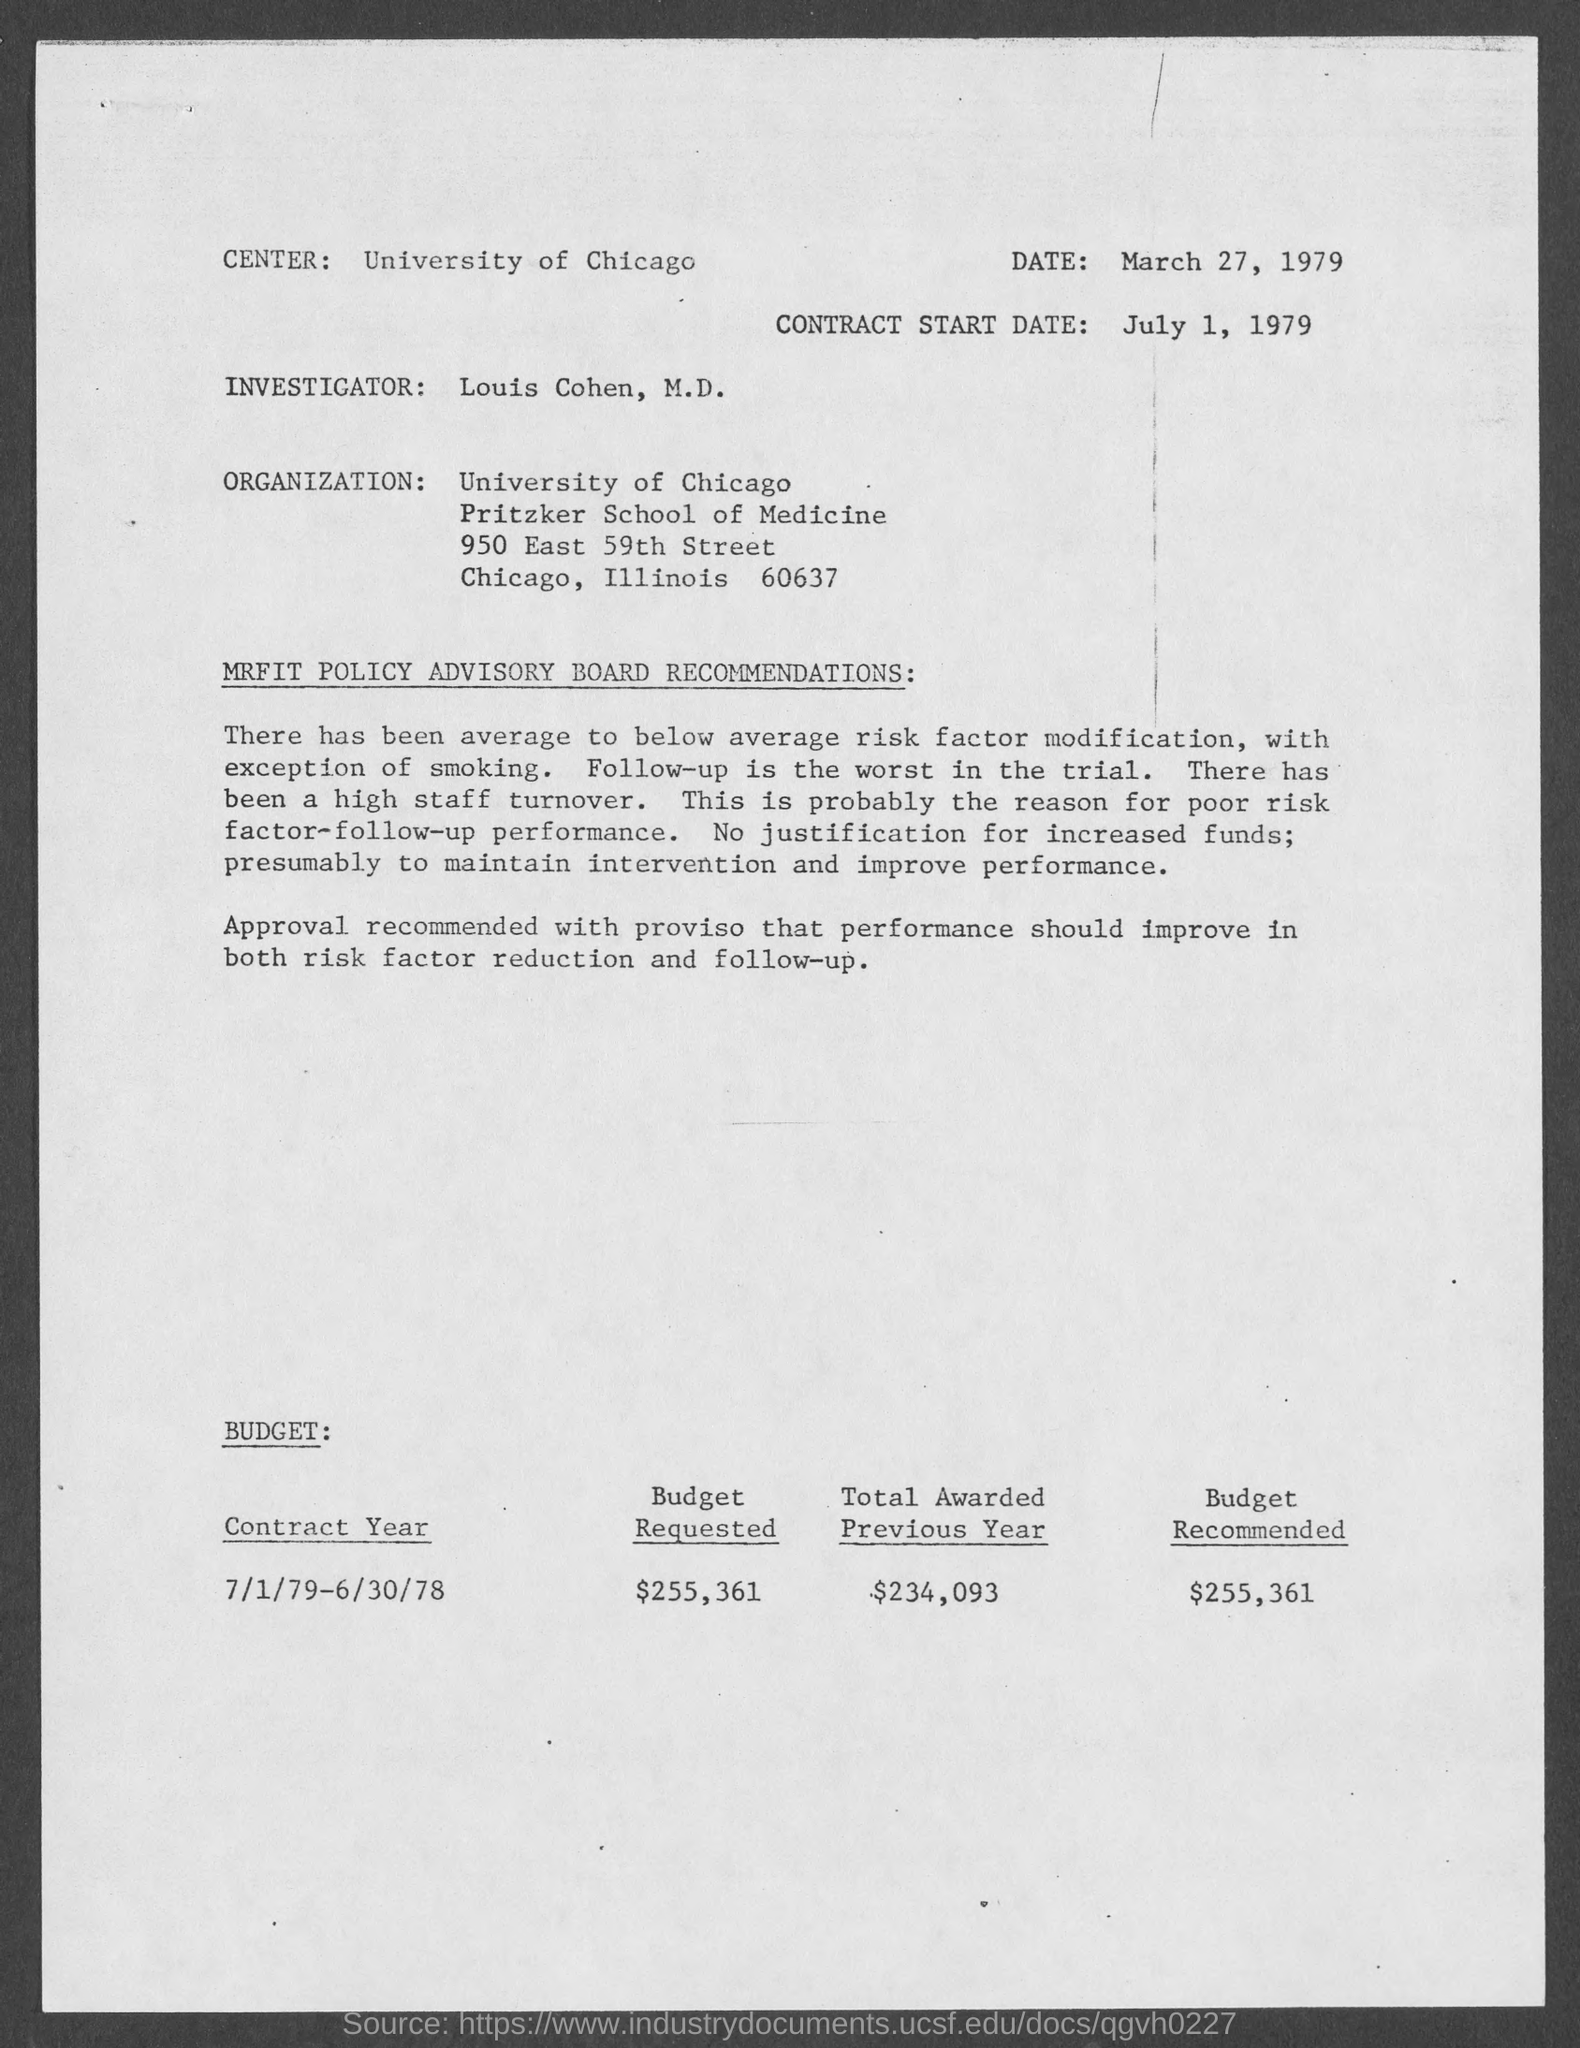Indicate a few pertinent items in this graphic. The budget recommended is $255,361. The University of Chicago is located in the center. The investigator is Louis Cohen, M.D. The document is dated March 27, 1979. The contract start date is July 1, 1979. 